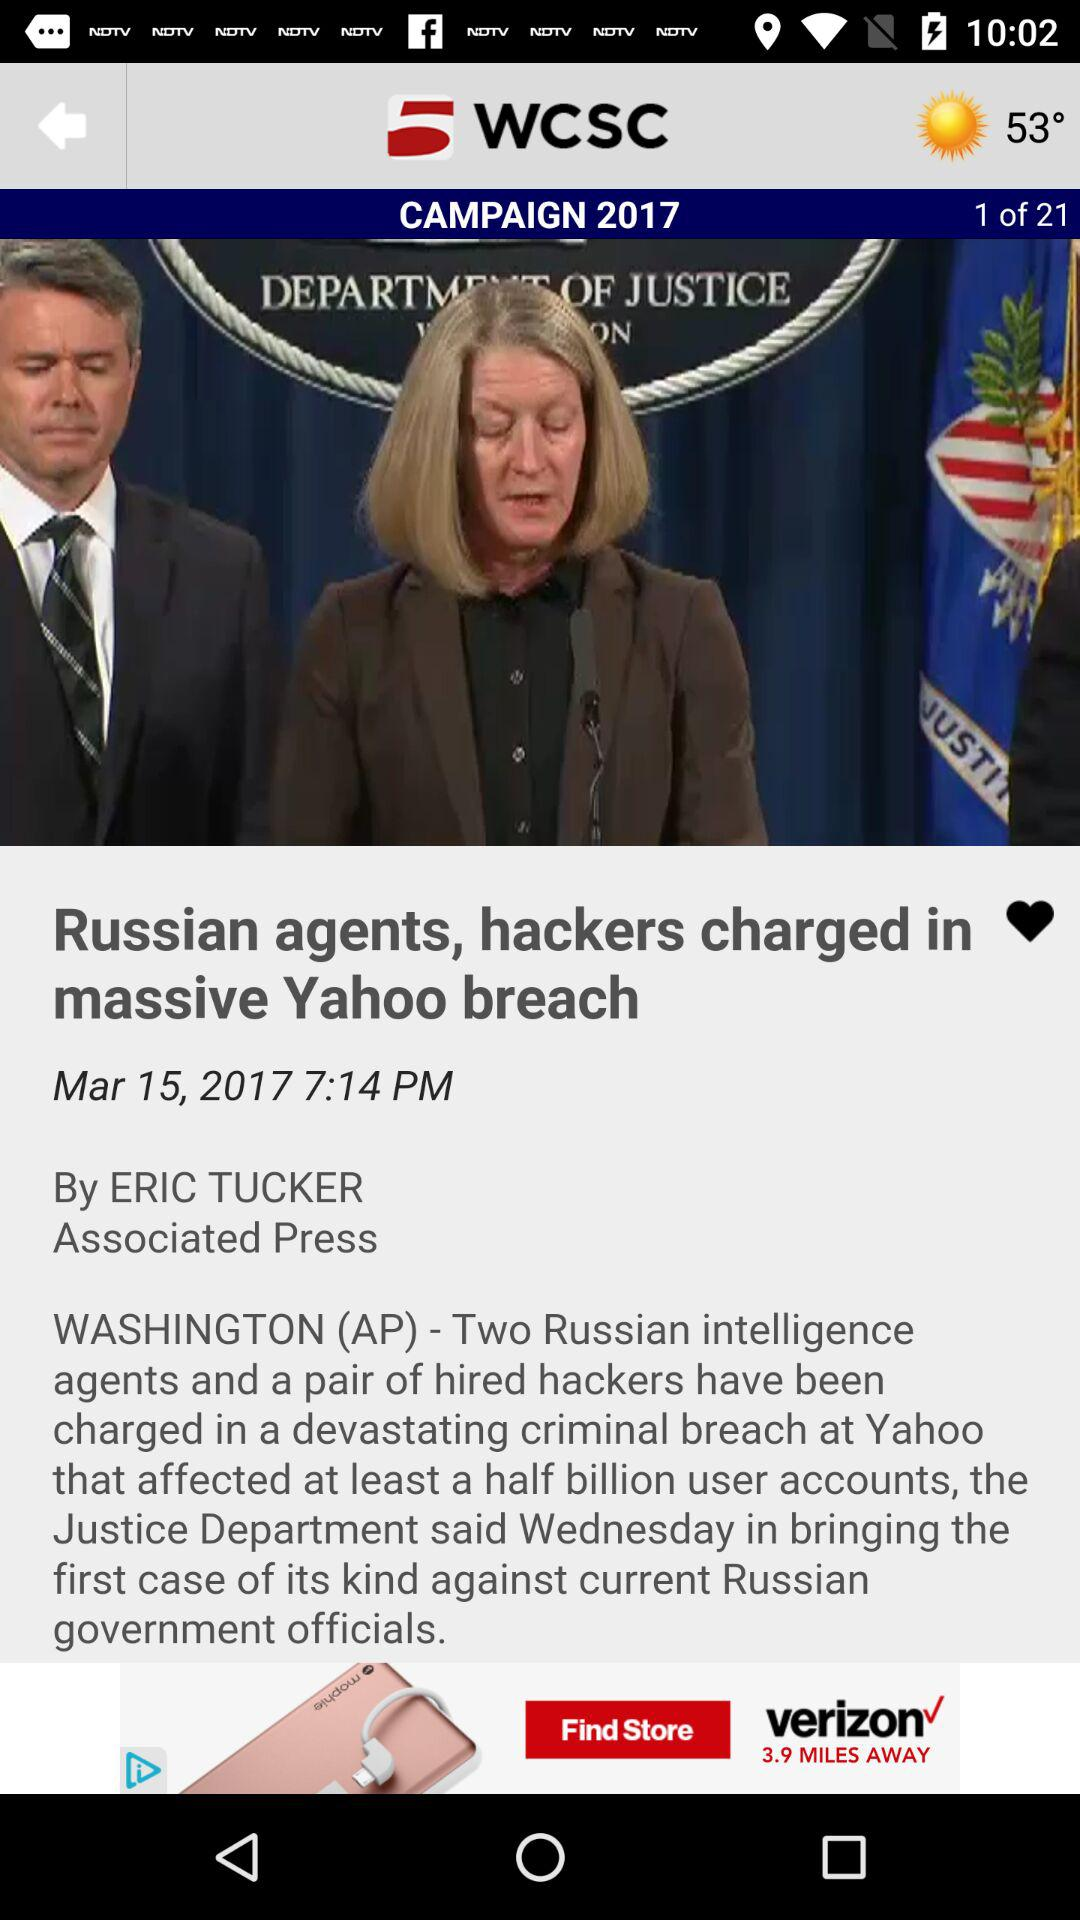What is the given temperature? The given temperature is 53°. 